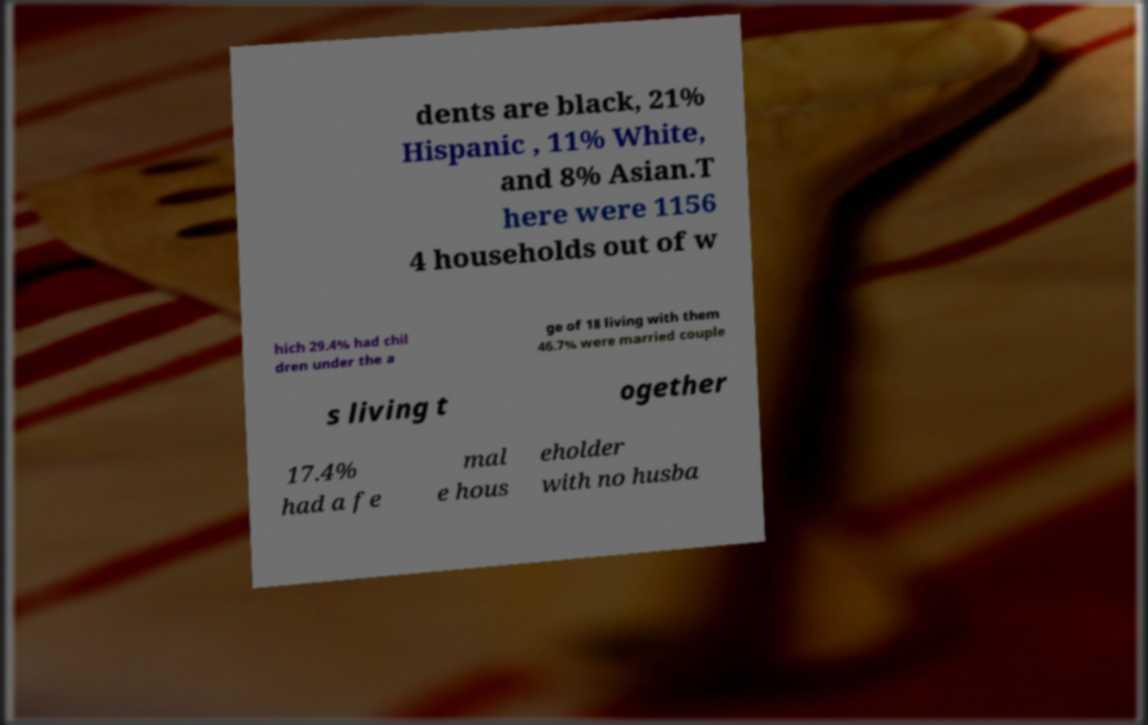I need the written content from this picture converted into text. Can you do that? dents are black, 21% Hispanic , 11% White, and 8% Asian.T here were 1156 4 households out of w hich 29.4% had chil dren under the a ge of 18 living with them 46.7% were married couple s living t ogether 17.4% had a fe mal e hous eholder with no husba 